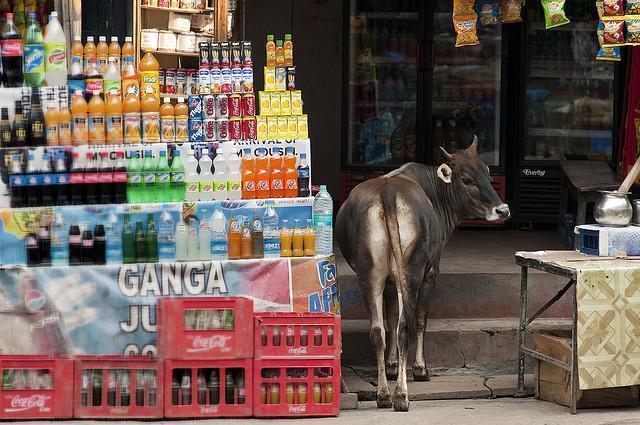The first five letters in white that are on the sign are used in spelling what style?
Select the accurate response from the four choices given to answer the question.
Options: Bohemian, gangnam, grunge, tiger. Gangnam. 